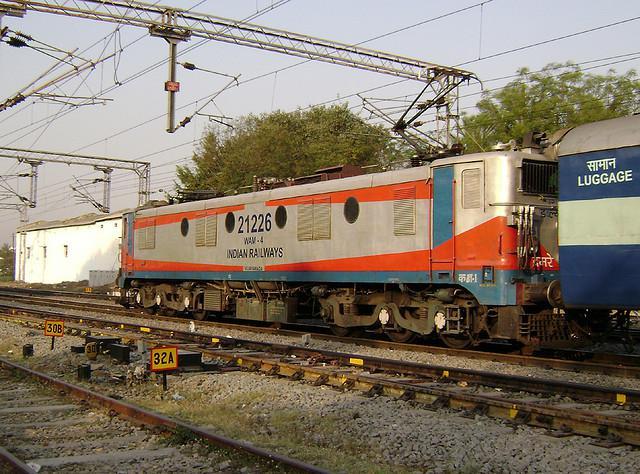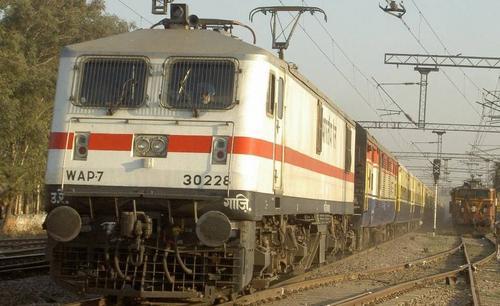The first image is the image on the left, the second image is the image on the right. Analyze the images presented: Is the assertion "A green train, with yellow trim and two square end windows, is sitting on the tracks on a sunny day." valid? Answer yes or no. No. 